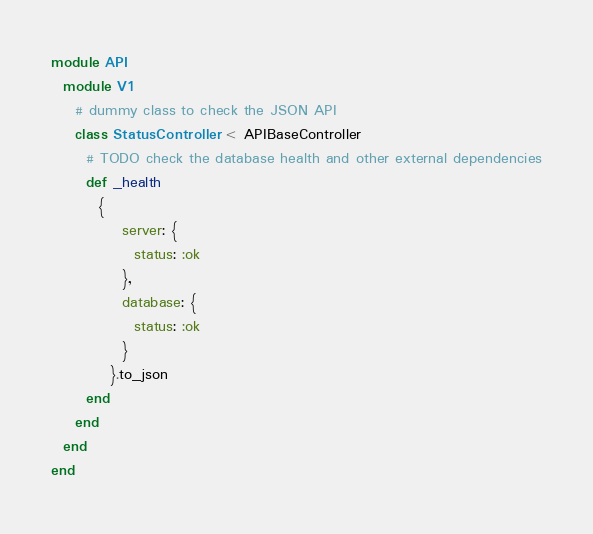Convert code to text. <code><loc_0><loc_0><loc_500><loc_500><_Crystal_>module API
  module V1
    # dummy class to check the JSON API
    class StatusController < APIBaseController
      # TODO check the database health and other external dependencies
      def _health
        {
            server: {
              status: :ok
            },
            database: {
              status: :ok
            }
          }.to_json
      end
    end
  end
end
</code> 